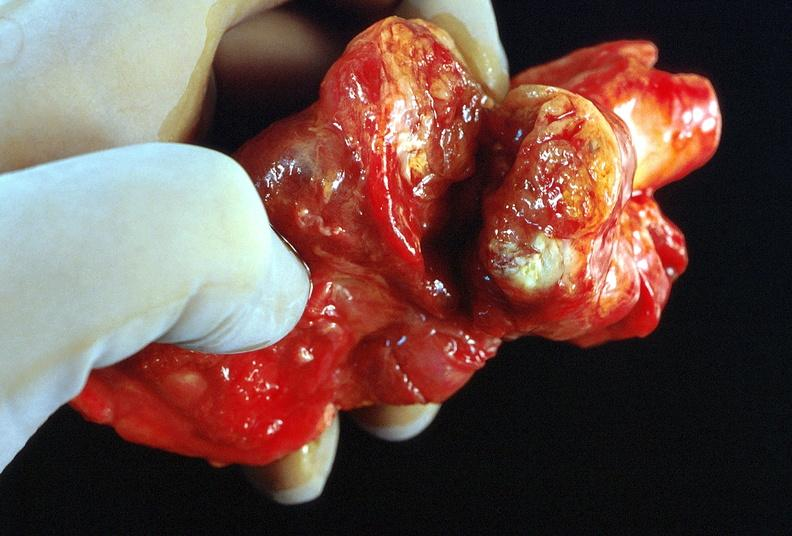what is present?
Answer the question using a single word or phrase. Endocrine 